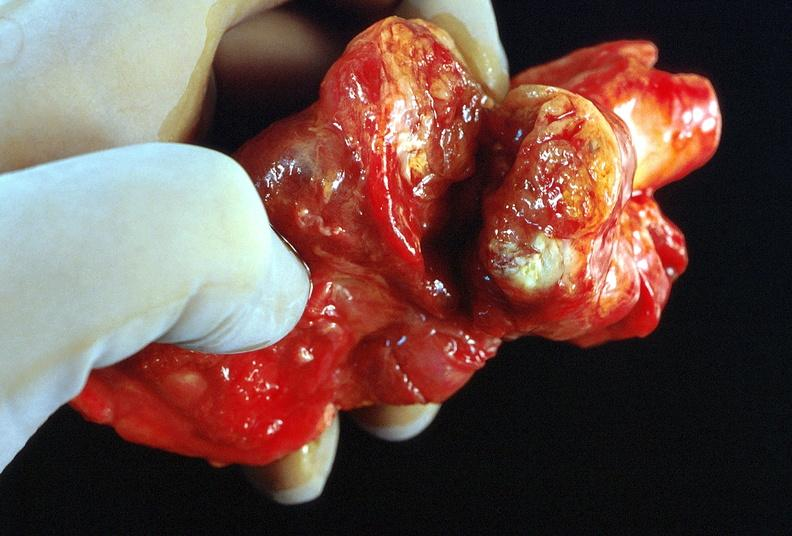what is present?
Answer the question using a single word or phrase. Endocrine 